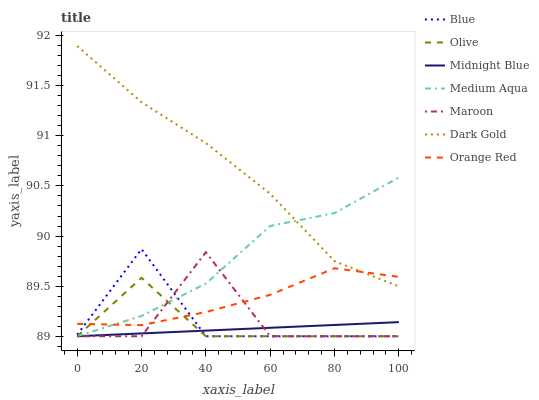Does Midnight Blue have the minimum area under the curve?
Answer yes or no. Yes. Does Dark Gold have the maximum area under the curve?
Answer yes or no. Yes. Does Dark Gold have the minimum area under the curve?
Answer yes or no. No. Does Midnight Blue have the maximum area under the curve?
Answer yes or no. No. Is Midnight Blue the smoothest?
Answer yes or no. Yes. Is Maroon the roughest?
Answer yes or no. Yes. Is Dark Gold the smoothest?
Answer yes or no. No. Is Dark Gold the roughest?
Answer yes or no. No. Does Blue have the lowest value?
Answer yes or no. Yes. Does Dark Gold have the lowest value?
Answer yes or no. No. Does Dark Gold have the highest value?
Answer yes or no. Yes. Does Midnight Blue have the highest value?
Answer yes or no. No. Is Blue less than Dark Gold?
Answer yes or no. Yes. Is Orange Red greater than Midnight Blue?
Answer yes or no. Yes. Does Medium Aqua intersect Olive?
Answer yes or no. Yes. Is Medium Aqua less than Olive?
Answer yes or no. No. Is Medium Aqua greater than Olive?
Answer yes or no. No. Does Blue intersect Dark Gold?
Answer yes or no. No. 